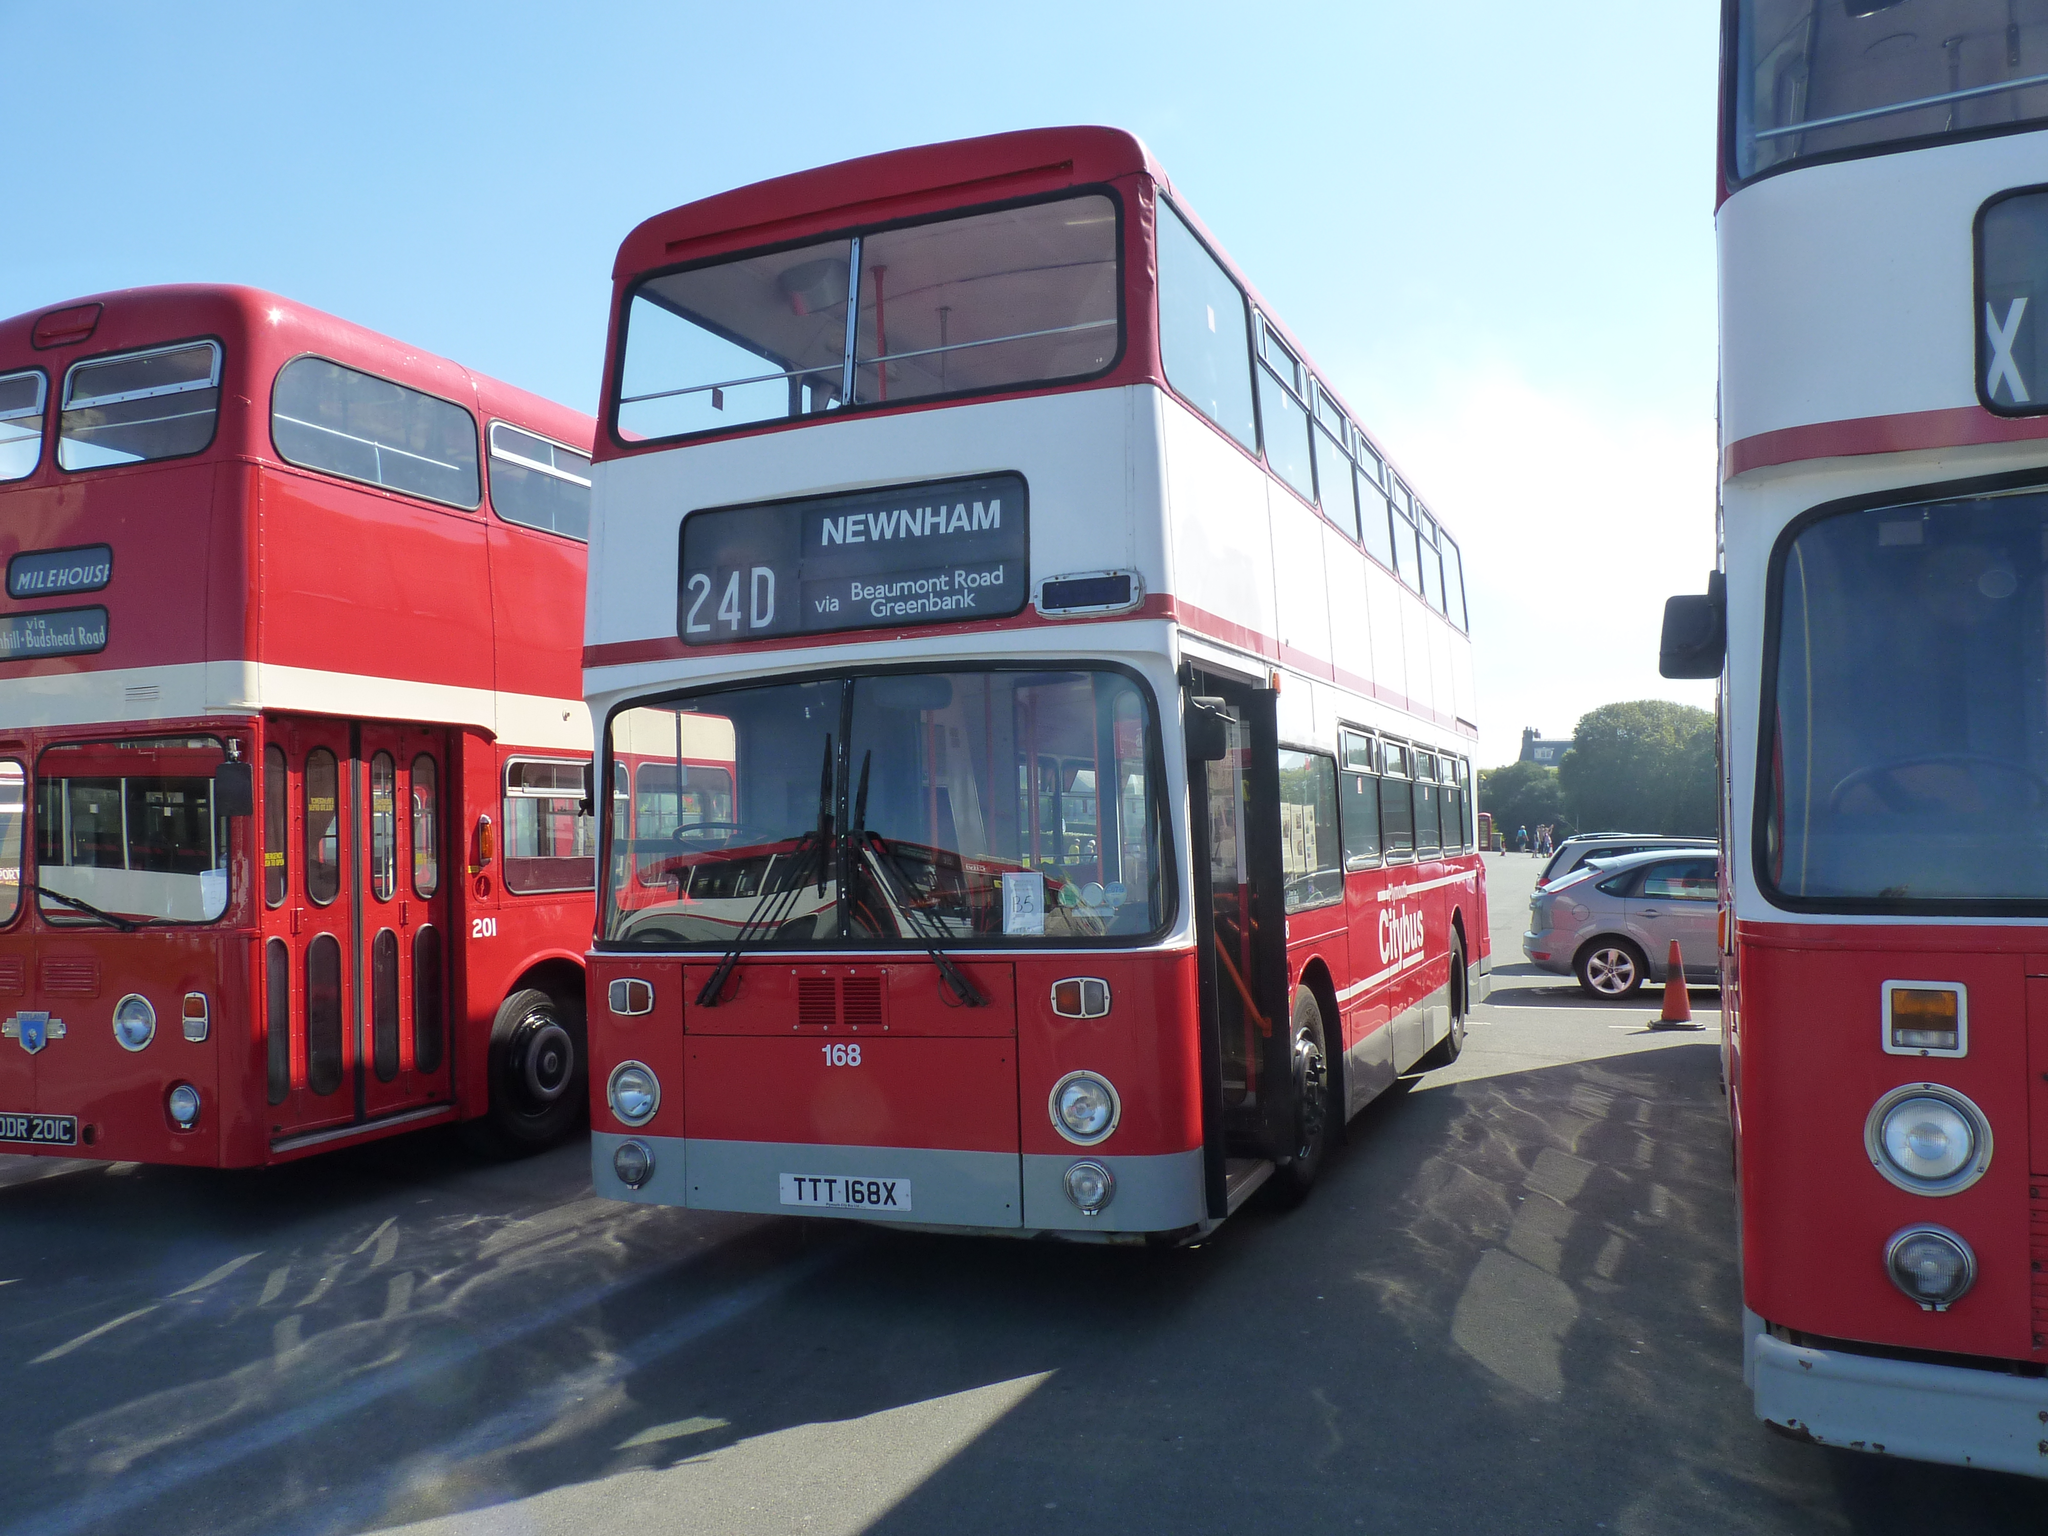<image>
Create a compact narrative representing the image presented. Bus # 24D Newnham Beaumont Road Greenbank with number 168 and TTT168X on the bottom. 